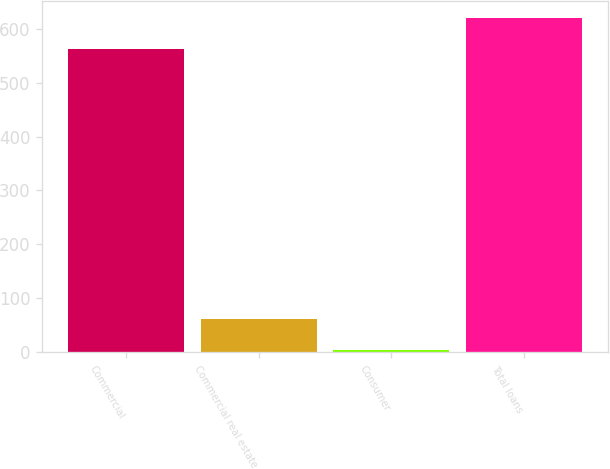Convert chart. <chart><loc_0><loc_0><loc_500><loc_500><bar_chart><fcel>Commercial<fcel>Commercial real estate<fcel>Consumer<fcel>Total loans<nl><fcel>563<fcel>62.1<fcel>4<fcel>621.1<nl></chart> 